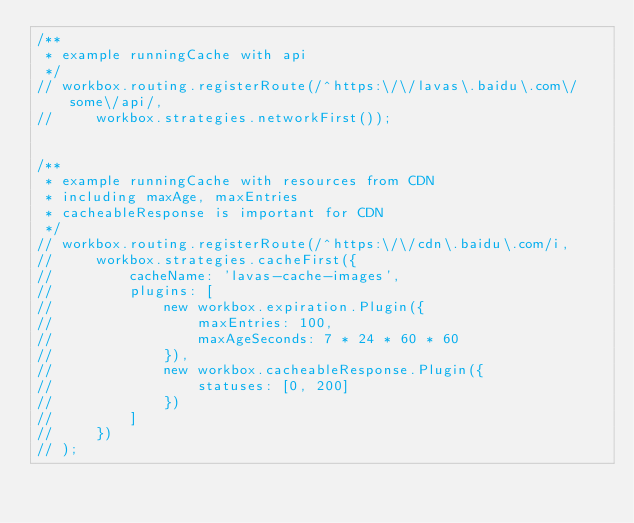Convert code to text. <code><loc_0><loc_0><loc_500><loc_500><_JavaScript_>/**
 * example runningCache with api
 */
// workbox.routing.registerRoute(/^https:\/\/lavas\.baidu\.com\/some\/api/,
//     workbox.strategies.networkFirst());


/**
 * example runningCache with resources from CDN
 * including maxAge, maxEntries
 * cacheableResponse is important for CDN
 */
// workbox.routing.registerRoute(/^https:\/\/cdn\.baidu\.com/i,
//     workbox.strategies.cacheFirst({
//         cacheName: 'lavas-cache-images',
//         plugins: [
//             new workbox.expiration.Plugin({
//                 maxEntries: 100,
//                 maxAgeSeconds: 7 * 24 * 60 * 60
//             }),
//             new workbox.cacheableResponse.Plugin({
//                 statuses: [0, 200]
//             })
//         ]
//     })
// );
</code> 